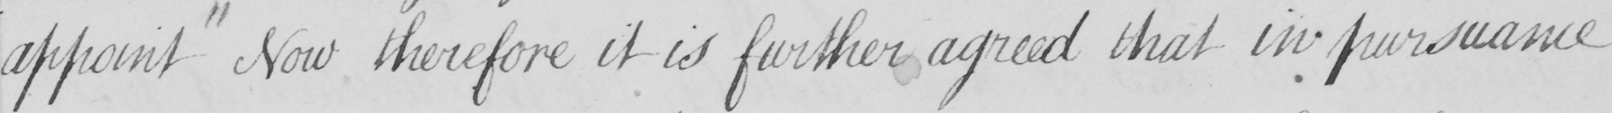What text is written in this handwritten line? appoint Now therefore it is further agreed that in pursuance 